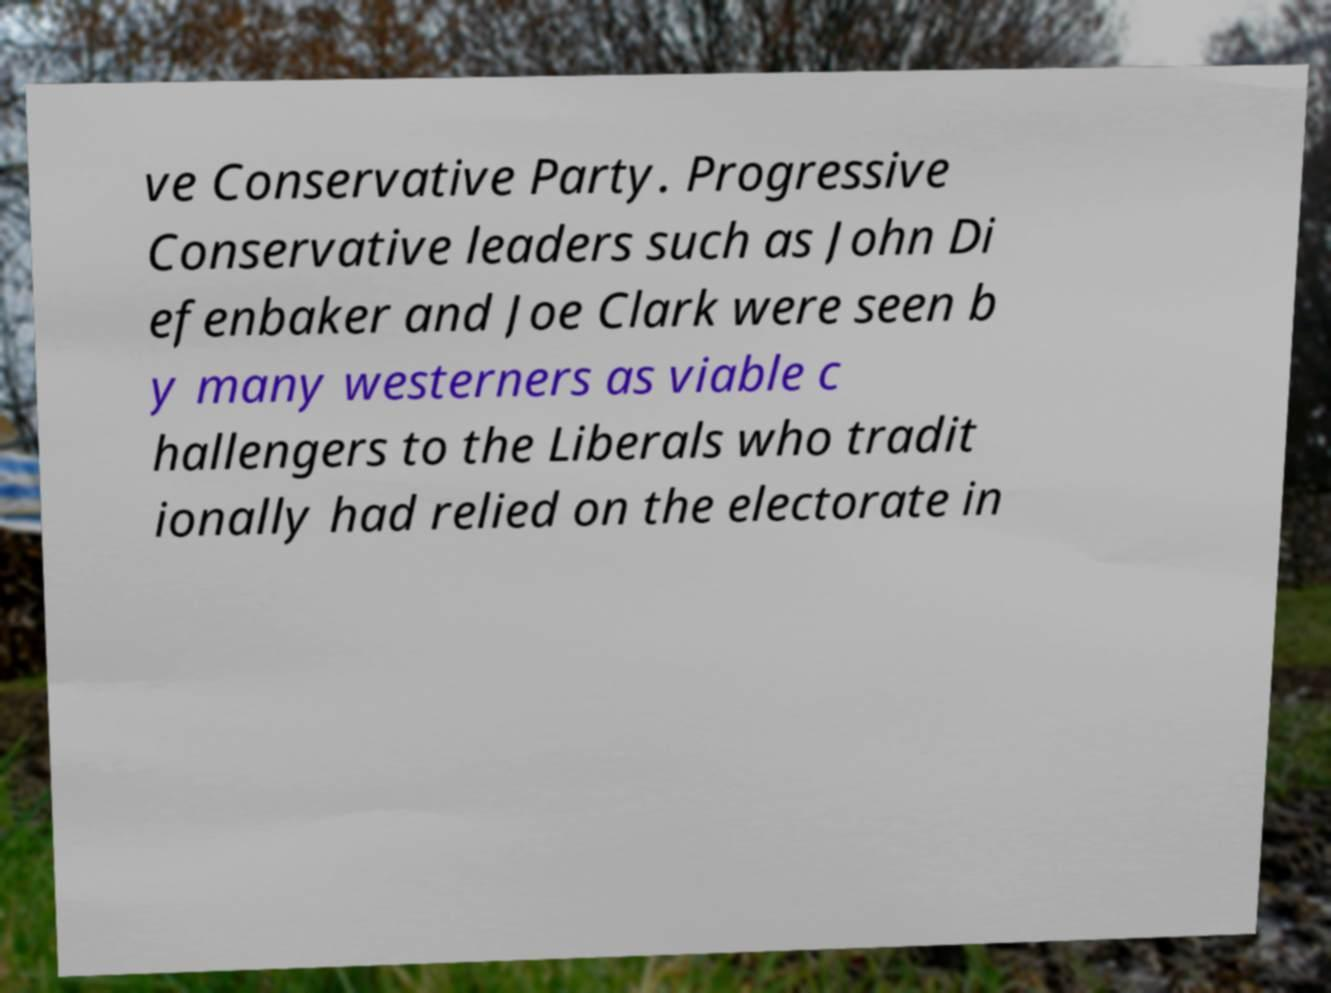I need the written content from this picture converted into text. Can you do that? ve Conservative Party. Progressive Conservative leaders such as John Di efenbaker and Joe Clark were seen b y many westerners as viable c hallengers to the Liberals who tradit ionally had relied on the electorate in 